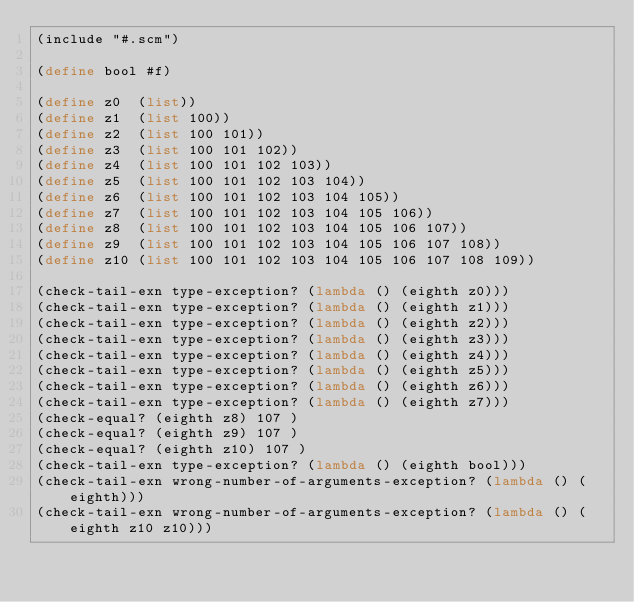<code> <loc_0><loc_0><loc_500><loc_500><_Scheme_>(include "#.scm")

(define bool #f)

(define z0  (list))
(define z1  (list 100))
(define z2  (list 100 101))
(define z3  (list 100 101 102))
(define z4  (list 100 101 102 103))
(define z5  (list 100 101 102 103 104))
(define z6  (list 100 101 102 103 104 105))
(define z7  (list 100 101 102 103 104 105 106))
(define z8  (list 100 101 102 103 104 105 106 107))
(define z9  (list 100 101 102 103 104 105 106 107 108))
(define z10 (list 100 101 102 103 104 105 106 107 108 109))

(check-tail-exn type-exception? (lambda () (eighth z0)))
(check-tail-exn type-exception? (lambda () (eighth z1)))
(check-tail-exn type-exception? (lambda () (eighth z2)))
(check-tail-exn type-exception? (lambda () (eighth z3)))
(check-tail-exn type-exception? (lambda () (eighth z4)))
(check-tail-exn type-exception? (lambda () (eighth z5)))
(check-tail-exn type-exception? (lambda () (eighth z6)))
(check-tail-exn type-exception? (lambda () (eighth z7)))
(check-equal? (eighth z8) 107 )
(check-equal? (eighth z9) 107 )
(check-equal? (eighth z10) 107 )
(check-tail-exn type-exception? (lambda () (eighth bool)))
(check-tail-exn wrong-number-of-arguments-exception? (lambda () (eighth)))
(check-tail-exn wrong-number-of-arguments-exception? (lambda () (eighth z10 z10)))
</code> 